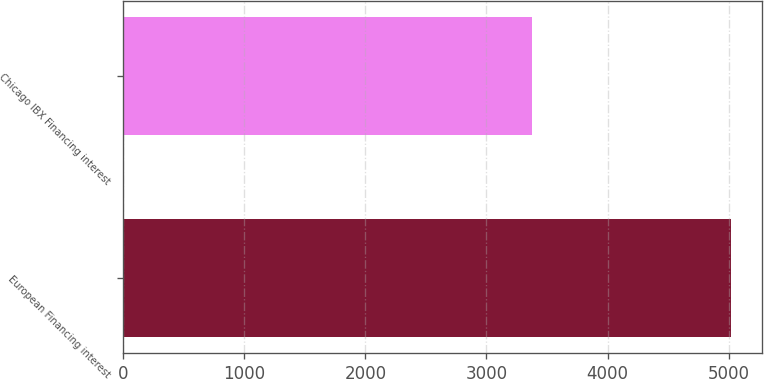<chart> <loc_0><loc_0><loc_500><loc_500><bar_chart><fcel>European Financing interest<fcel>Chicago IBX Financing interest<nl><fcel>5023<fcel>3379<nl></chart> 